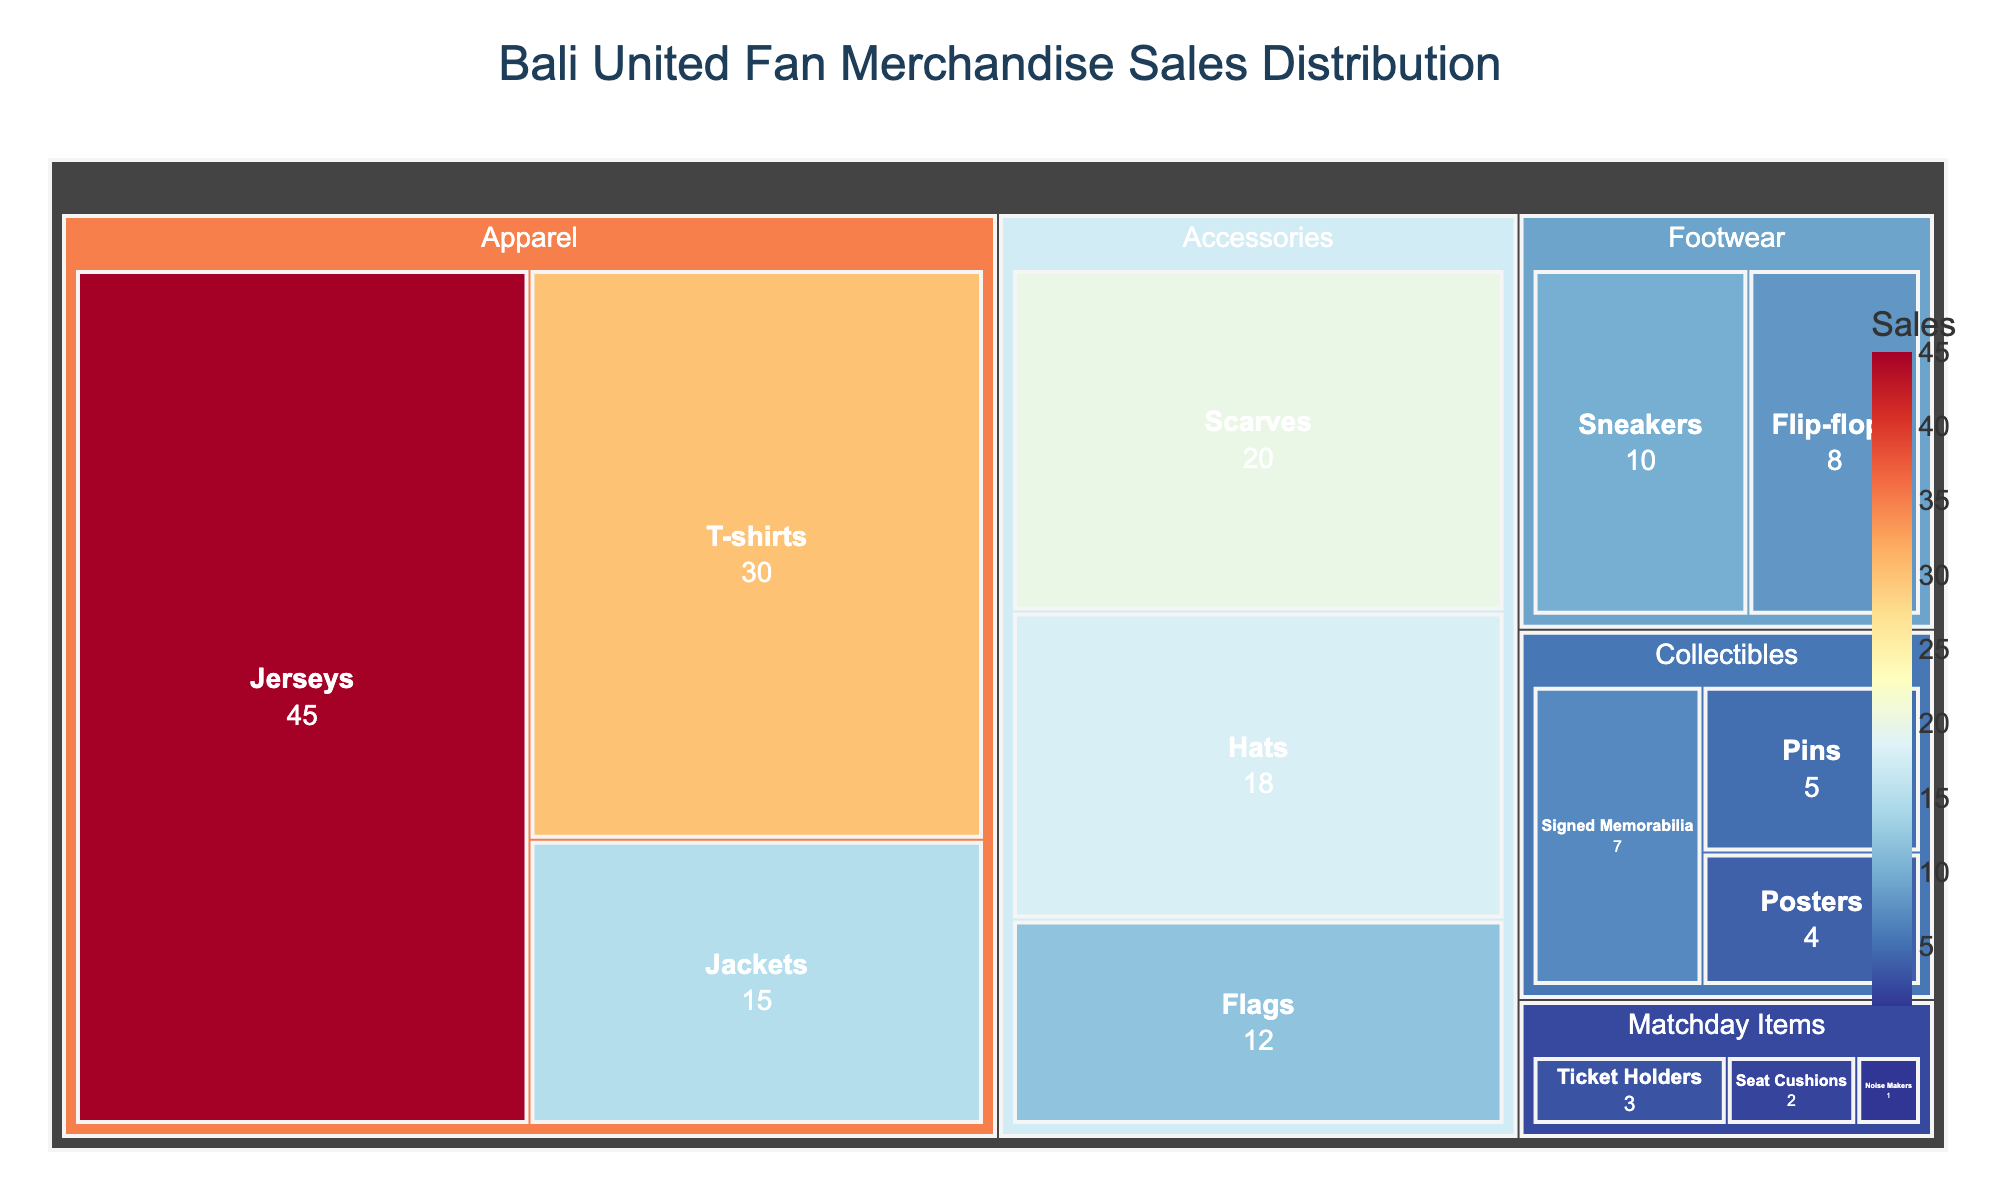what is the title of the figure? The title is located at the top of the treemap and typically gives an overview of what the figure represents. In this case, it says "Bali United Fan Merchandise Sales Distribution".
Answer: Bali United Fan Merchandise Sales Distribution Which subcategory under 'Apparel' has the highest sales? Under the 'Apparel' category, compare the values of each subcategory. 'Jerseys' has the highest value of 45.
Answer: Jerseys How many categories have sales values greater than 15? Check each category and sum the subcategories' values that are greater than 15. 'Apparel' (Jerseys, T-shirts, Jackets), and 'Accessories' (Scarves, Hats) fit the criteria.
Answer: 2 What's the difference in sales between 'Jerseys' and 'Hats'? Subtract the sales value of 'Hats' from 'Jerseys'. 'Jerseys' have 45 and 'Hats' have 18, so 45 - 18 = 27.
Answer: 27 Which category has the smallest total value, and what is it? Sum the values for each category and compare. 'Matchday Items' has the smallest total: Ticket Holders (3) + Seat Cushions (2) + Noise Makers (1) = 6.
Answer: Matchday Items, 6 What are the total sales for all subcategories under 'Accessories'? Sum the sales values for Scarves (20), Hats (18), and Flags (12). 20 + 18 + 12 = 50.
Answer: 50 Which subcategory has the least sales and how much? Identify the smallest value among all subcategories, which is 'Noise Makers' with a value of 1.
Answer: Noise Makers, 1 Which of 'Footwear' subcategories sold more, 'Sneakers' or 'Flip-flops'? Compare the sales values: 'Sneakers' (10) vs. 'Flip-flops' (8). 'Sneakers' has more sales.
Answer: Sneakers What's the combined sales total for all 'Collectibles' subcategories? Sum the sales values for Signed Memorabilia (7), Pins (5), and Posters (4). 7 + 5 + 4 = 16.
Answer: 16 Which subcategory within 'Apparel' has the least sales? Within 'Apparel', compare the sales for Jerseys (45), T-shirts (30), and Jackets (15). Jackets have the least sales.
Answer: Jackets 